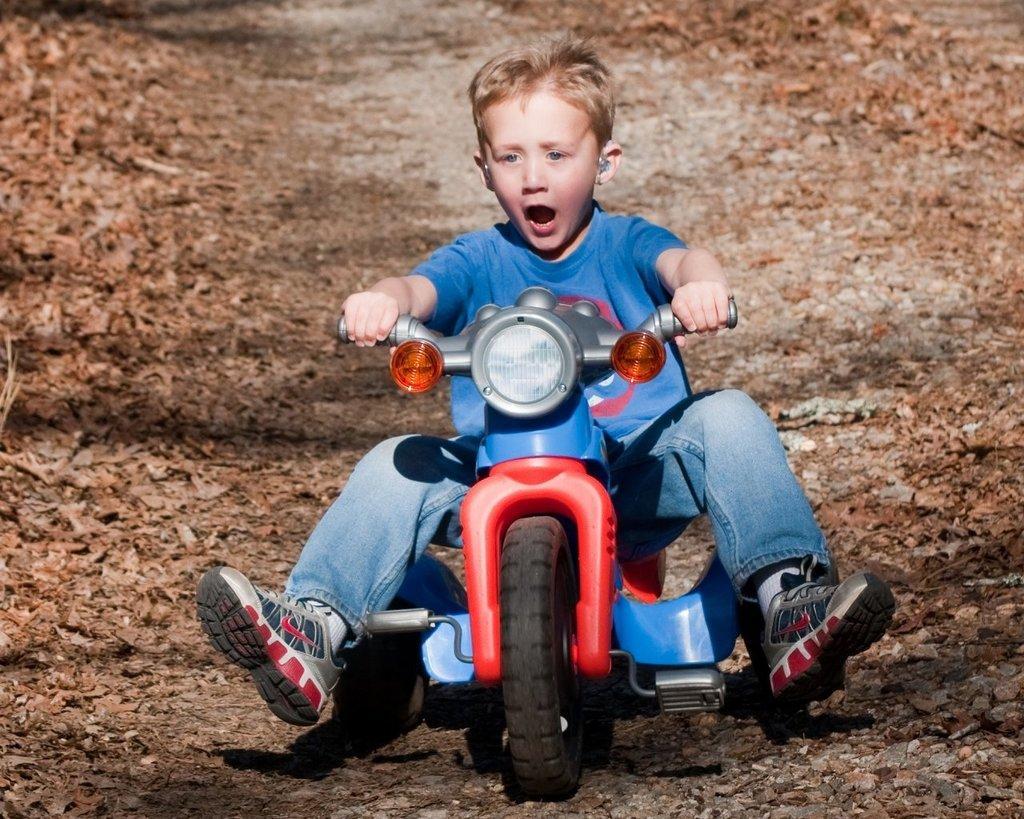In one or two sentences, can you explain what this image depicts? This picture is clicked outside. In the center there is a kid wearing blue color t-shirt and riding a bike. In the background we can see the ground and the dry leaves and we can see the gravels. 